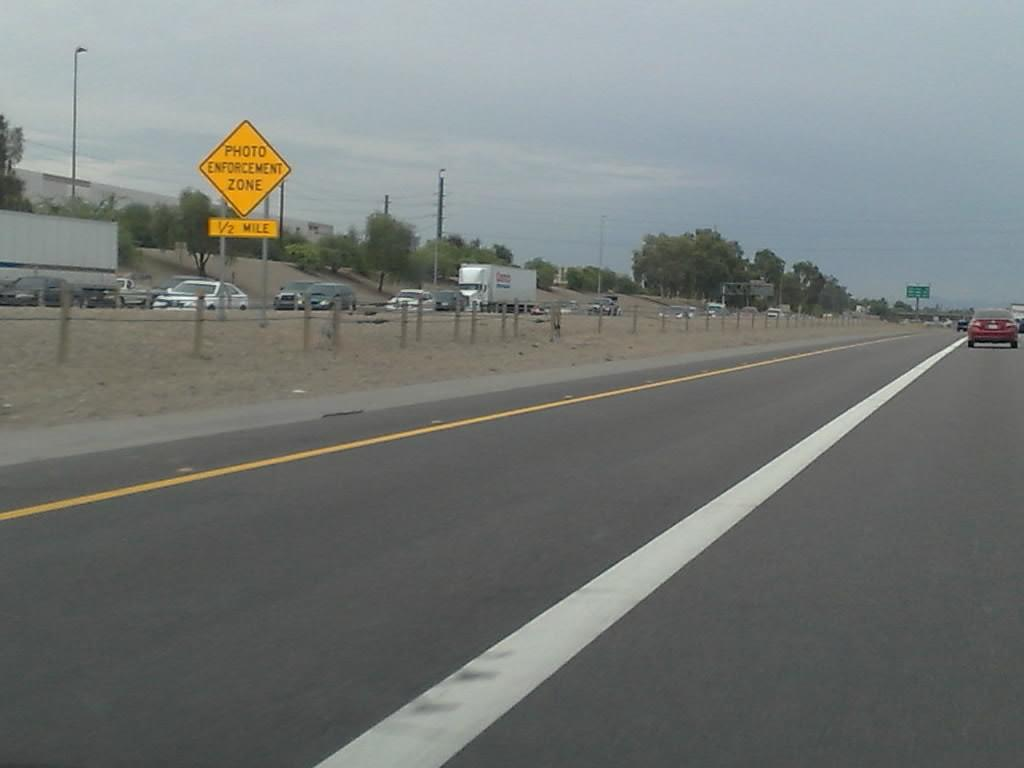<image>
Render a clear and concise summary of the photo. A road sign that warns of a photo enforcement zone in a half mile. 